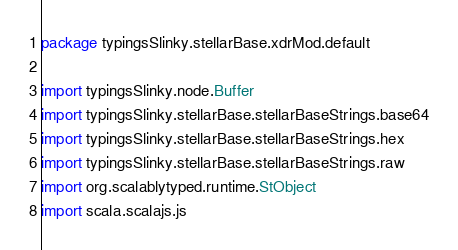<code> <loc_0><loc_0><loc_500><loc_500><_Scala_>package typingsSlinky.stellarBase.xdrMod.default

import typingsSlinky.node.Buffer
import typingsSlinky.stellarBase.stellarBaseStrings.base64
import typingsSlinky.stellarBase.stellarBaseStrings.hex
import typingsSlinky.stellarBase.stellarBaseStrings.raw
import org.scalablytyped.runtime.StObject
import scala.scalajs.js</code> 